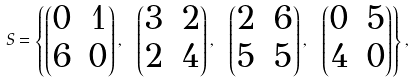Convert formula to latex. <formula><loc_0><loc_0><loc_500><loc_500>S = \left \{ \begin{pmatrix} 0 & 1 \\ 6 & 0 \end{pmatrix} , \ \begin{pmatrix} 3 & 2 \\ 2 & 4 \end{pmatrix} , \ \begin{pmatrix} 2 & 6 \\ 5 & 5 \end{pmatrix} , \ \begin{pmatrix} 0 & 5 \\ 4 & 0 \end{pmatrix} \right \} ,</formula> 